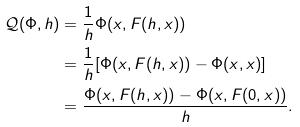<formula> <loc_0><loc_0><loc_500><loc_500>\mathcal { Q } ( \Phi , h ) & = \frac { 1 } { h } \Phi ( x , F ( h , x ) ) \\ & = \frac { 1 } { h } [ \Phi ( x , F ( h , x ) ) - \Phi ( x , x ) ] \\ & = \frac { \Phi ( x , F ( h , x ) ) - \Phi ( x , F ( 0 , x ) ) } { h } .</formula> 